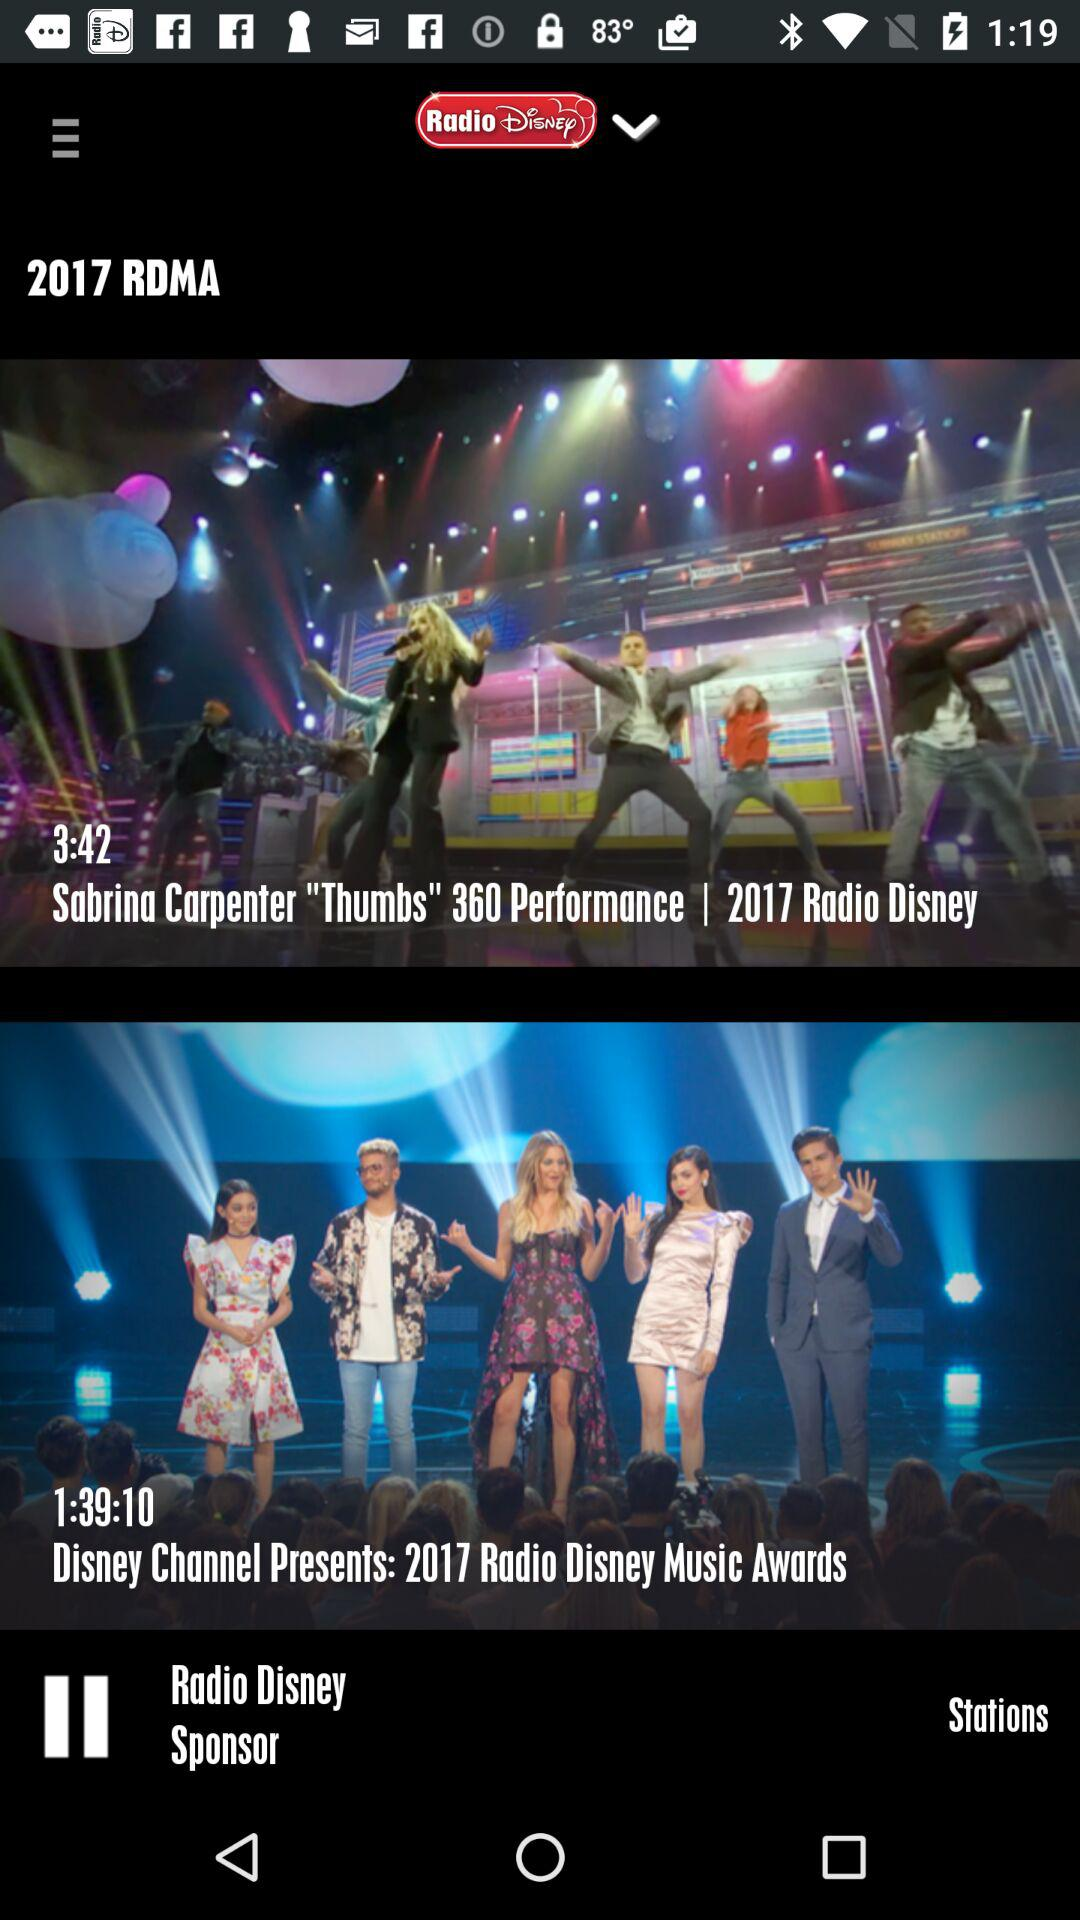Which radio station is playing? The radio station that is playing is "Radio Disney". 